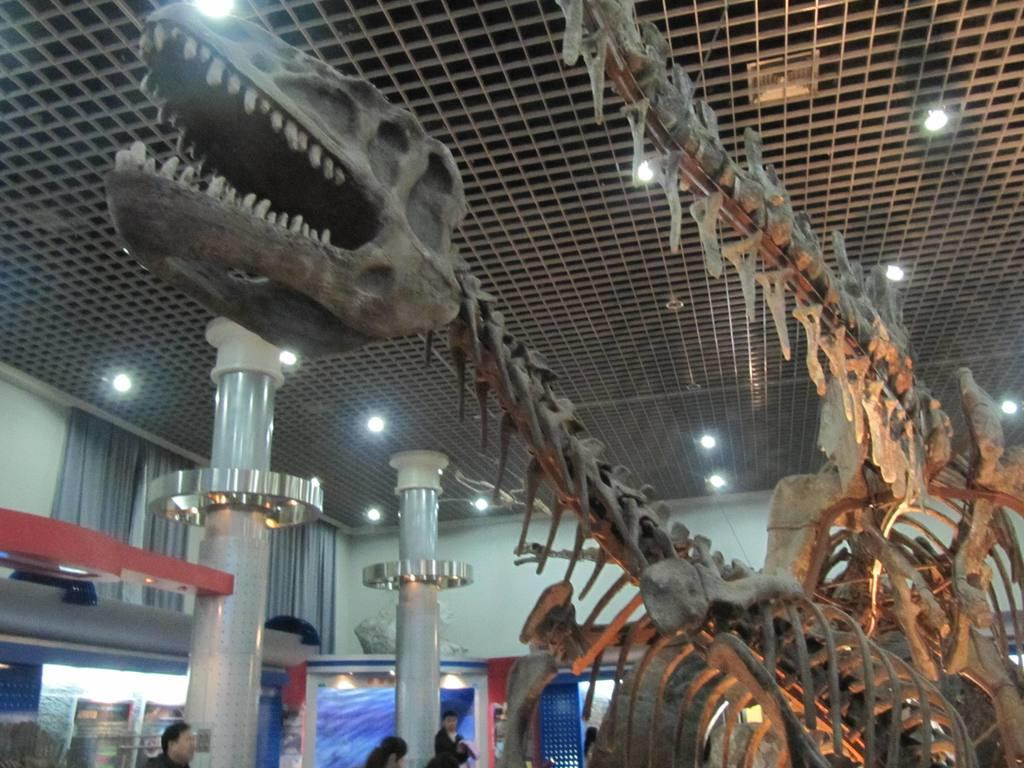What type of objects can be seen in the image related to animals? There are skeletons of animals in the image. What architectural features are present in the image? There are pillars in the image. Are there any people in the image? Yes, there are people in the image. What type of window treatment can be seen in the image? There are curtains in the image. What type of decorations are present in the image? There are posters in the image. What type of structure is visible in the image? There is a wall in the image. What type of lighting is visible in the image? There are lights visible at the top of the image. What is the size of the snails in the image? There are no snails present in the image. What day of the week is depicted in the image? The image does not depict a specific day of the week. 